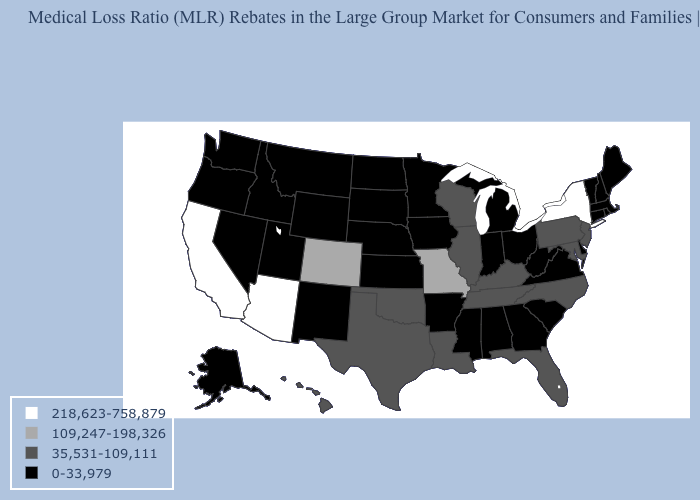What is the value of Georgia?
Keep it brief. 0-33,979. Among the states that border Ohio , which have the lowest value?
Answer briefly. Indiana, Michigan, West Virginia. What is the value of Michigan?
Answer briefly. 0-33,979. What is the value of Alaska?
Quick response, please. 0-33,979. Among the states that border Oregon , which have the highest value?
Concise answer only. California. What is the lowest value in the West?
Give a very brief answer. 0-33,979. Name the states that have a value in the range 35,531-109,111?
Give a very brief answer. Florida, Hawaii, Illinois, Kentucky, Louisiana, Maryland, New Jersey, North Carolina, Oklahoma, Pennsylvania, Tennessee, Texas, Wisconsin. What is the value of Louisiana?
Answer briefly. 35,531-109,111. Name the states that have a value in the range 109,247-198,326?
Quick response, please. Colorado, Missouri. Does the first symbol in the legend represent the smallest category?
Quick response, please. No. Name the states that have a value in the range 0-33,979?
Quick response, please. Alabama, Alaska, Arkansas, Connecticut, Delaware, Georgia, Idaho, Indiana, Iowa, Kansas, Maine, Massachusetts, Michigan, Minnesota, Mississippi, Montana, Nebraska, Nevada, New Hampshire, New Mexico, North Dakota, Ohio, Oregon, Rhode Island, South Carolina, South Dakota, Utah, Vermont, Virginia, Washington, West Virginia, Wyoming. What is the value of Virginia?
Answer briefly. 0-33,979. What is the value of Massachusetts?
Concise answer only. 0-33,979. What is the lowest value in the Northeast?
Keep it brief. 0-33,979. Does the map have missing data?
Quick response, please. No. 